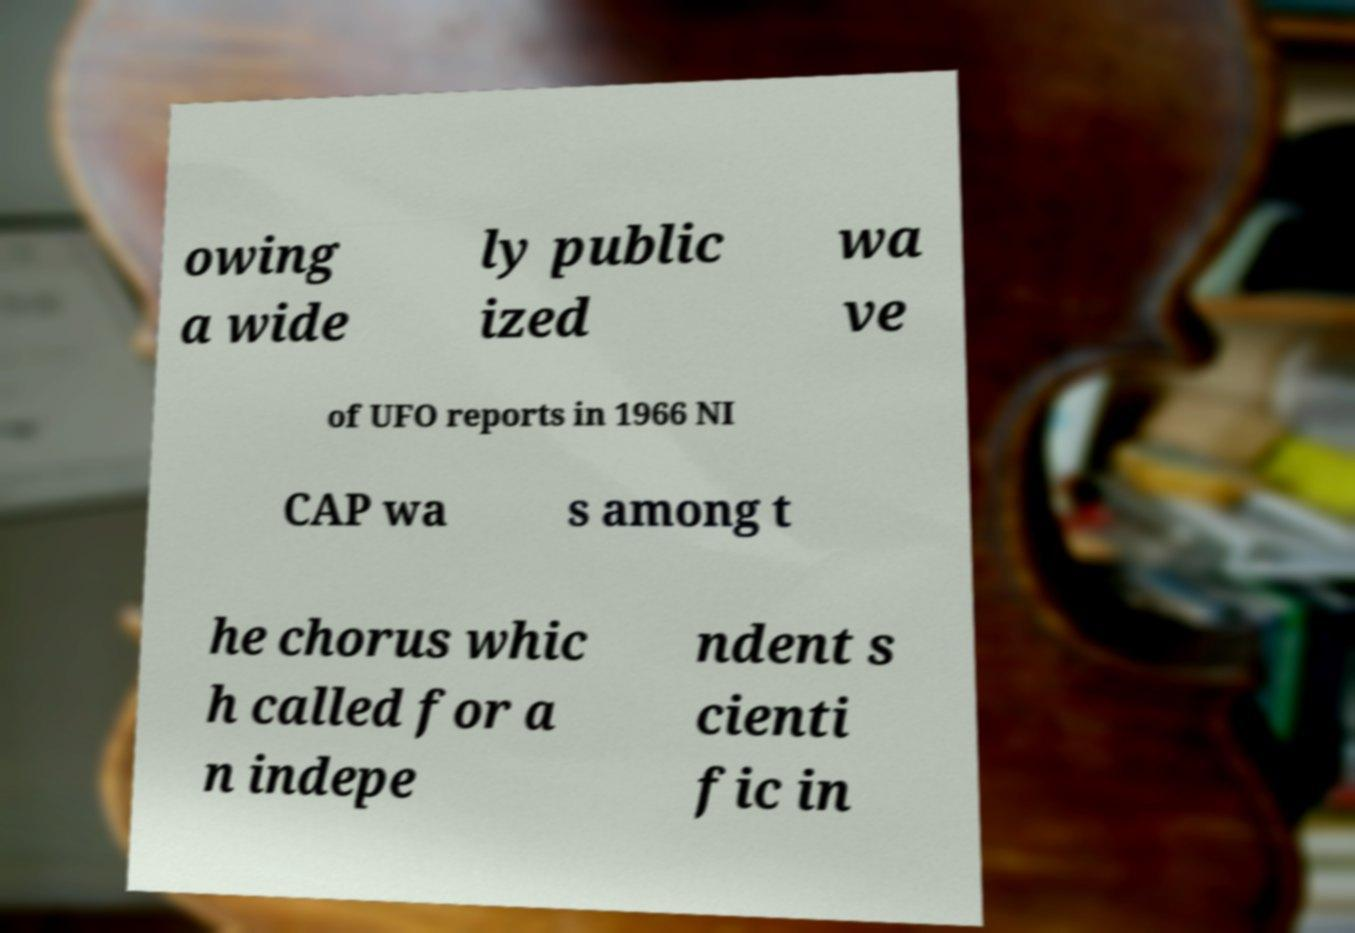I need the written content from this picture converted into text. Can you do that? owing a wide ly public ized wa ve of UFO reports in 1966 NI CAP wa s among t he chorus whic h called for a n indepe ndent s cienti fic in 